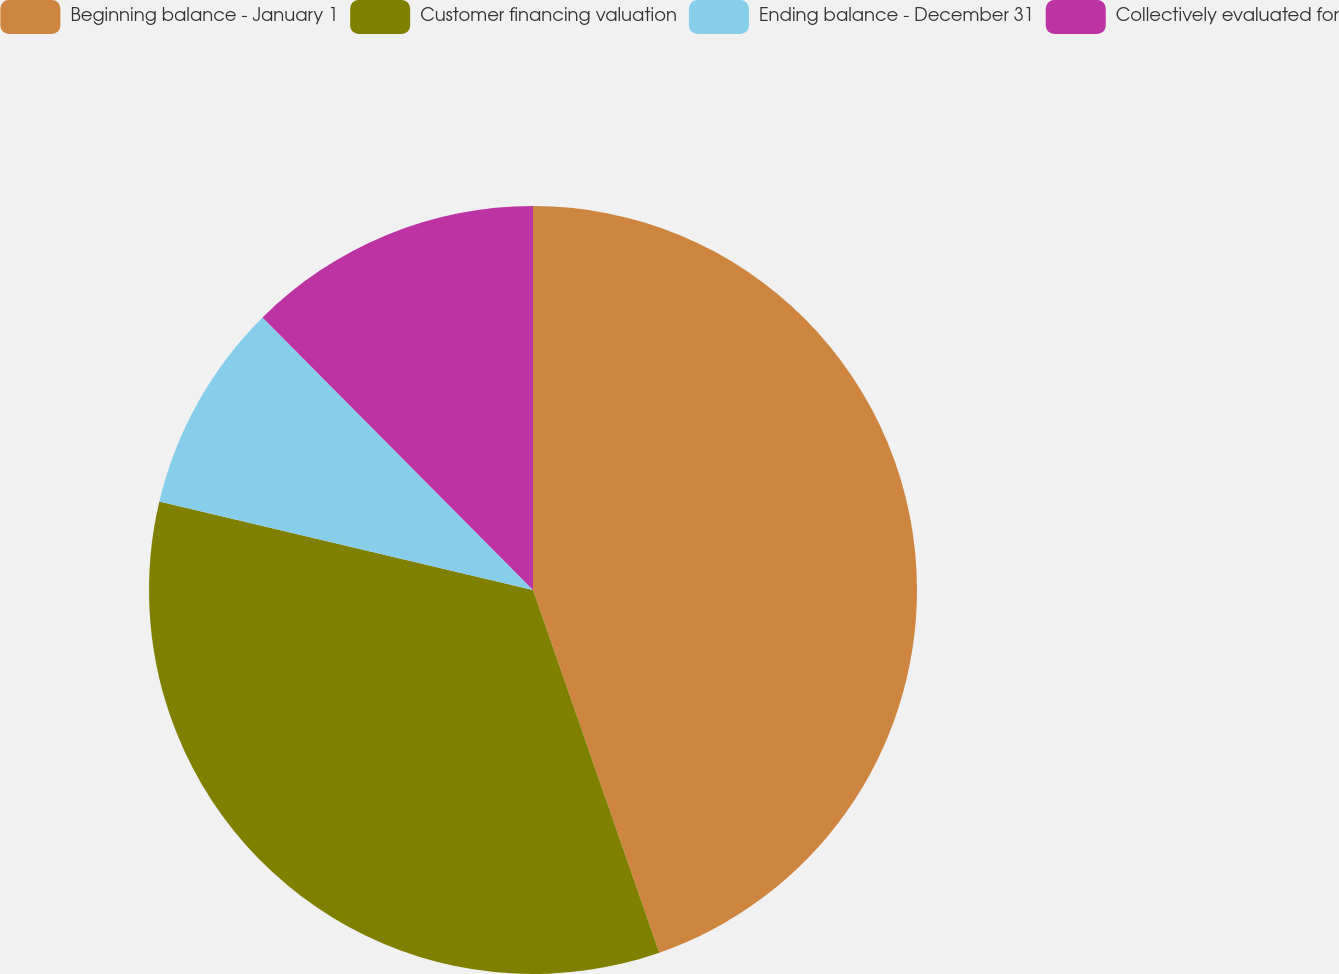Convert chart to OTSL. <chart><loc_0><loc_0><loc_500><loc_500><pie_chart><fcel>Beginning balance - January 1<fcel>Customer financing valuation<fcel>Ending balance - December 31<fcel>Collectively evaluated for<nl><fcel>44.67%<fcel>34.04%<fcel>8.86%<fcel>12.44%<nl></chart> 